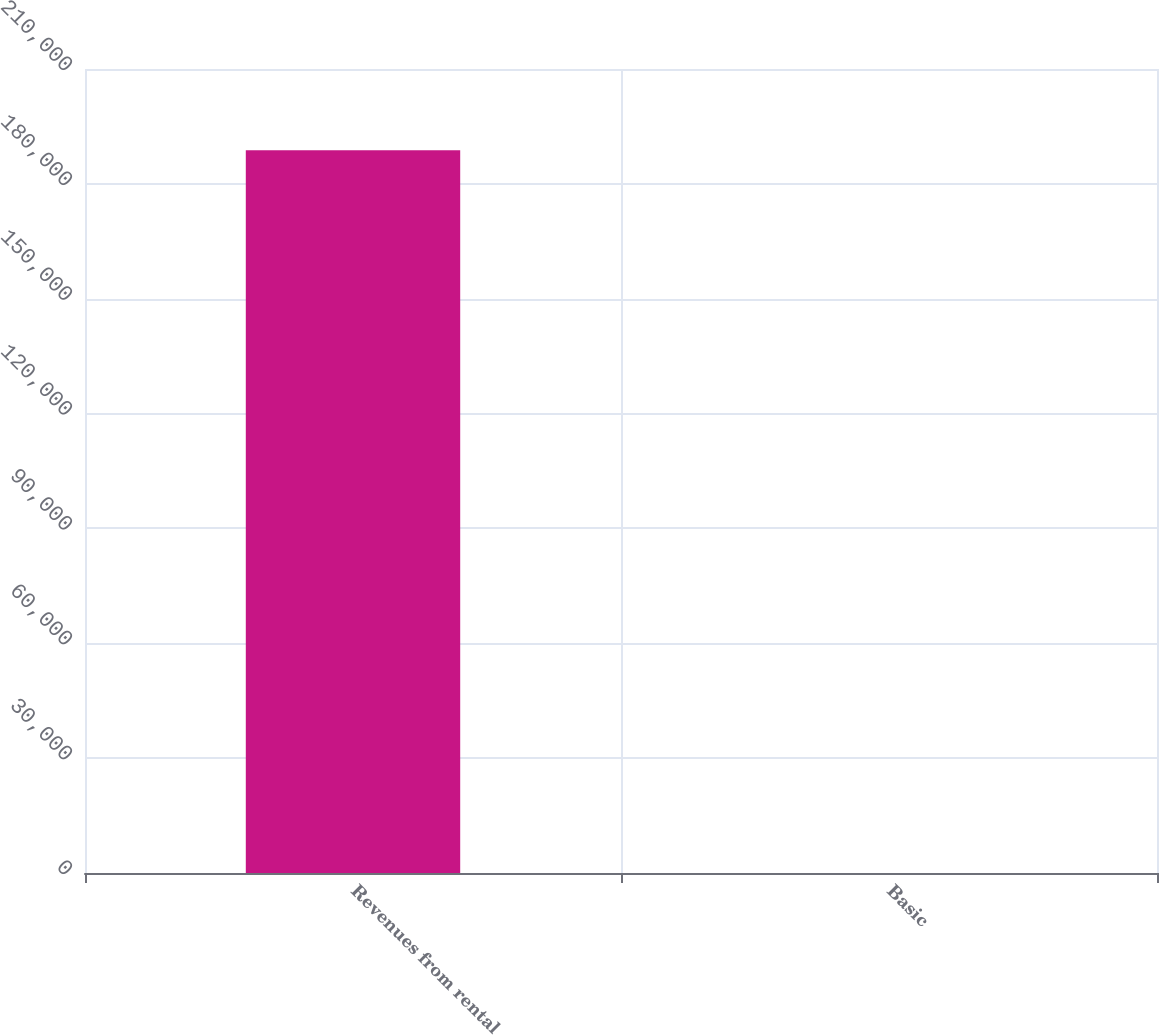<chart> <loc_0><loc_0><loc_500><loc_500><bar_chart><fcel>Revenues from rental<fcel>Basic<nl><fcel>188794<fcel>0.34<nl></chart> 